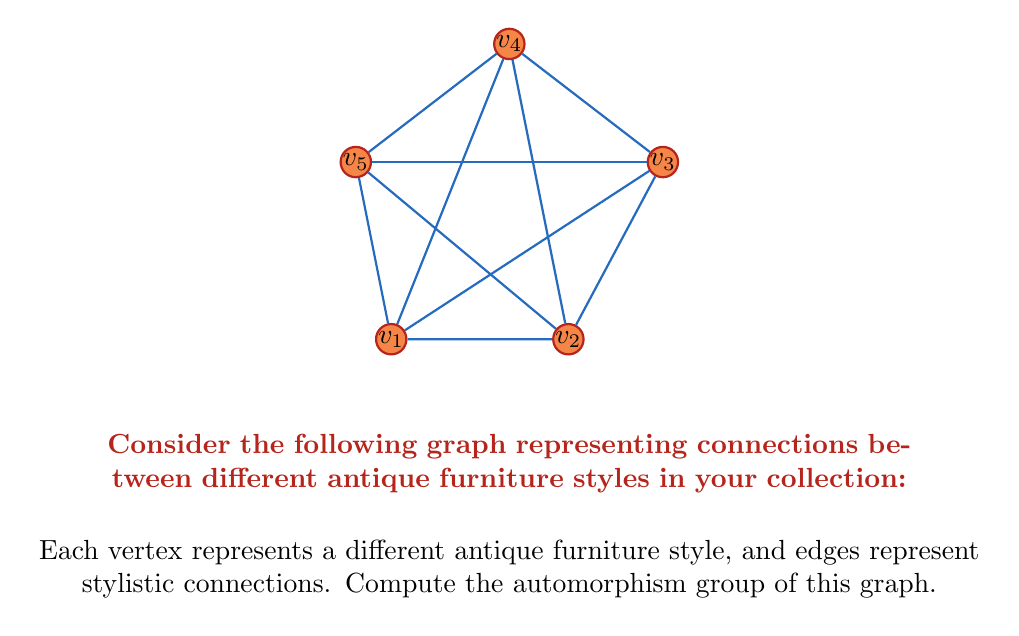Teach me how to tackle this problem. To find the automorphism group of this graph, we need to determine all possible permutations of vertices that preserve the graph structure. Let's approach this step-by-step:

1) First, observe that the graph has a pentagonal structure with additional diagonals.

2) The degree sequence of the vertices is (4, 4, 4, 4, 4), meaning all vertices have the same degree. This suggests that any vertex could potentially be mapped to any other vertex.

3) However, the diagonal structure restricts the possible automorphisms. Each vertex is connected to its two neighbors in the pentagon and two non-adjacent vertices.

4) The symmetry of the graph allows rotations by 72° (2π/5) and reflections across five axes.

5) The rotations form a cyclic group of order 5, generated by the permutation (v1 v2 v3 v4 v5).

6) The reflections can be represented by permutations like (v2 v5)(v3 v4), (v1 v5)(v2 v4), etc.

7) The combination of rotations and reflections forms the dihedral group D5, which has order 10.

8) We can verify that any automorphism of the graph must be an element of D5, as any other permutation would not preserve the graph structure.

Therefore, the automorphism group of this graph is isomorphic to the dihedral group D5.
Answer: $D_5$ 